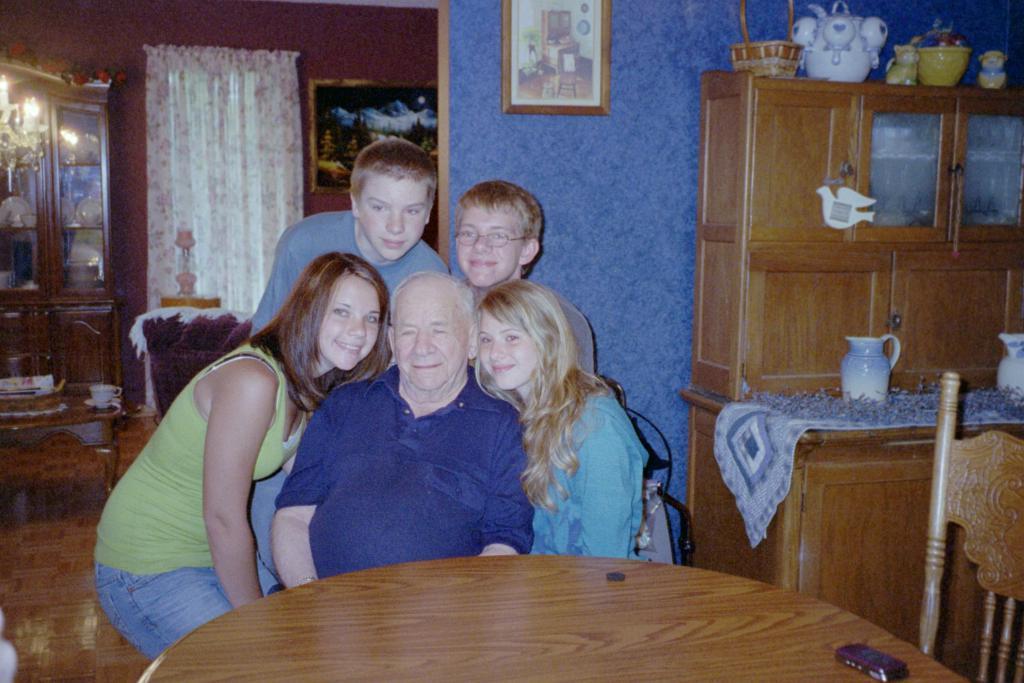How would you summarize this image in a sentence or two? In the center we can see group of persons were sitting on the chair around the table and they were smiling. In the background there is a wall,curtain,photo frame,cupboard,pot,cloth and flower. 